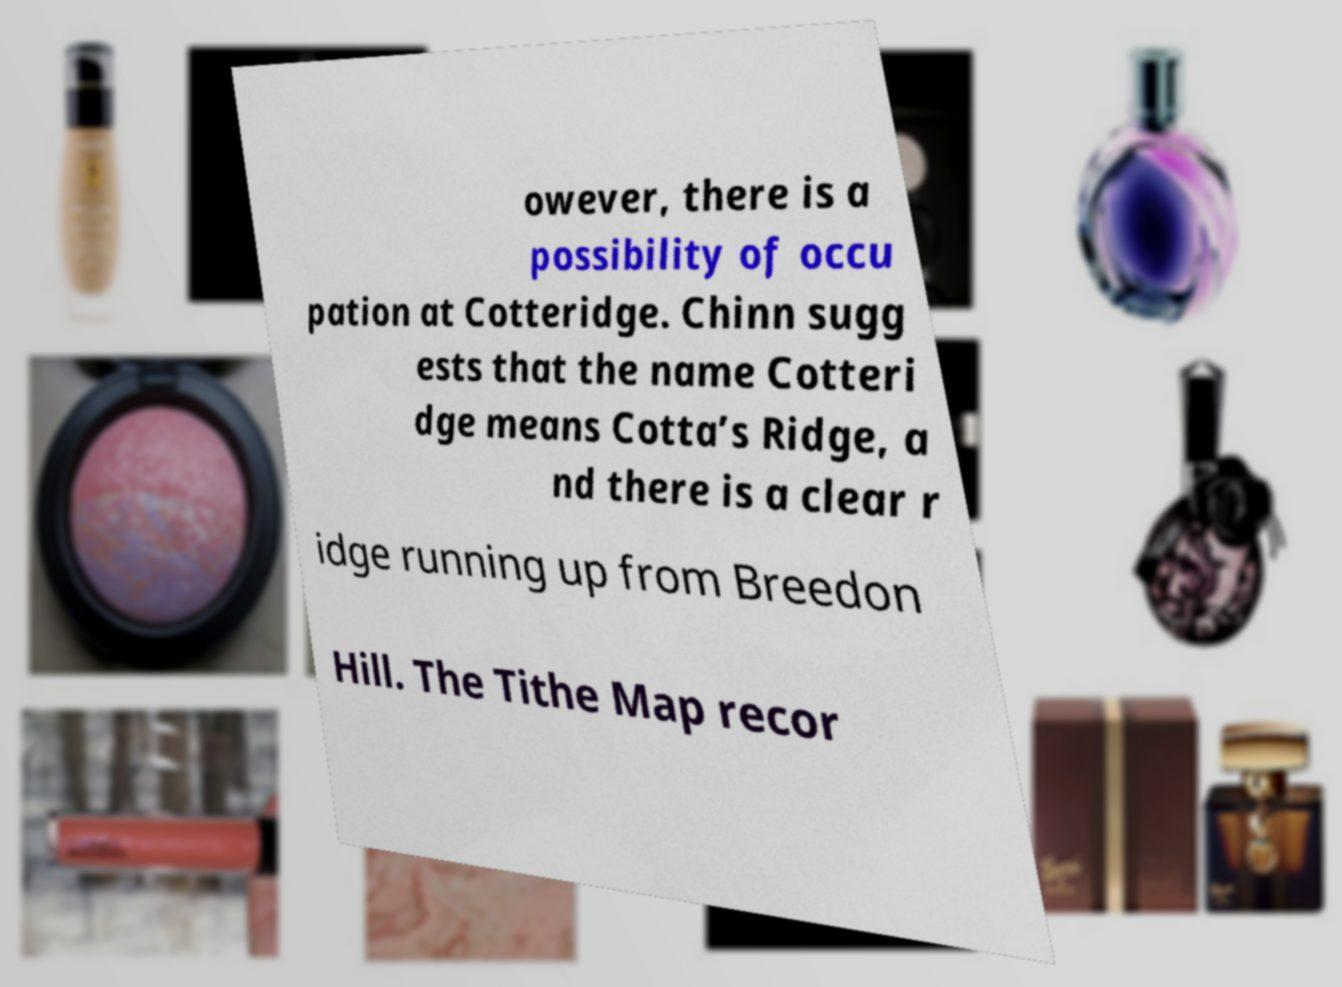I need the written content from this picture converted into text. Can you do that? owever, there is a possibility of occu pation at Cotteridge. Chinn sugg ests that the name Cotteri dge means Cotta’s Ridge, a nd there is a clear r idge running up from Breedon Hill. The Tithe Map recor 